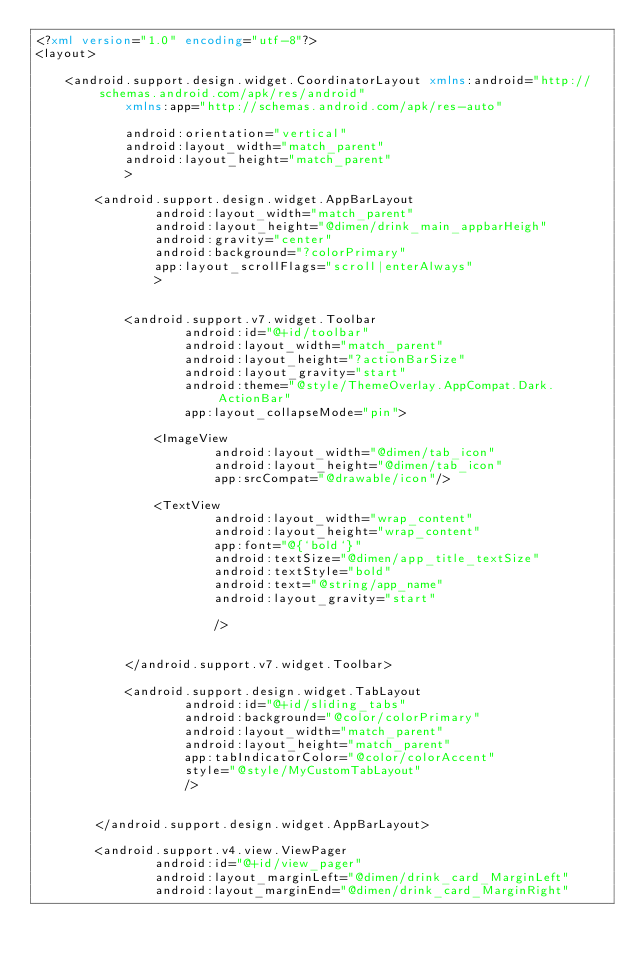Convert code to text. <code><loc_0><loc_0><loc_500><loc_500><_XML_><?xml version="1.0" encoding="utf-8"?>
<layout>

	<android.support.design.widget.CoordinatorLayout xmlns:android="http://schemas.android.com/apk/res/android"
			xmlns:app="http://schemas.android.com/apk/res-auto"

			android:orientation="vertical"
			android:layout_width="match_parent"
			android:layout_height="match_parent"
			>

		<android.support.design.widget.AppBarLayout
				android:layout_width="match_parent"
				android:layout_height="@dimen/drink_main_appbarHeigh"
				android:gravity="center"
				android:background="?colorPrimary"
				app:layout_scrollFlags="scroll|enterAlways"
				>


			<android.support.v7.widget.Toolbar
					android:id="@+id/toolbar"
					android:layout_width="match_parent"
					android:layout_height="?actionBarSize"
					android:layout_gravity="start"
					android:theme="@style/ThemeOverlay.AppCompat.Dark.ActionBar"
					app:layout_collapseMode="pin">

				<ImageView
						android:layout_width="@dimen/tab_icon"
						android:layout_height="@dimen/tab_icon"
						app:srcCompat="@drawable/icon"/>

				<TextView
						android:layout_width="wrap_content"
						android:layout_height="wrap_content"
						app:font="@{`bold`}"
						android:textSize="@dimen/app_title_textSize"
						android:textStyle="bold"
						android:text="@string/app_name"
						android:layout_gravity="start"

						/>


			</android.support.v7.widget.Toolbar>

			<android.support.design.widget.TabLayout
					android:id="@+id/sliding_tabs"
					android:background="@color/colorPrimary"
					android:layout_width="match_parent"
					android:layout_height="match_parent"
					app:tabIndicatorColor="@color/colorAccent"
					style="@style/MyCustomTabLayout"
					/>


		</android.support.design.widget.AppBarLayout>

		<android.support.v4.view.ViewPager
				android:id="@+id/view_pager"
				android:layout_marginLeft="@dimen/drink_card_MarginLeft"
				android:layout_marginEnd="@dimen/drink_card_MarginRight"</code> 